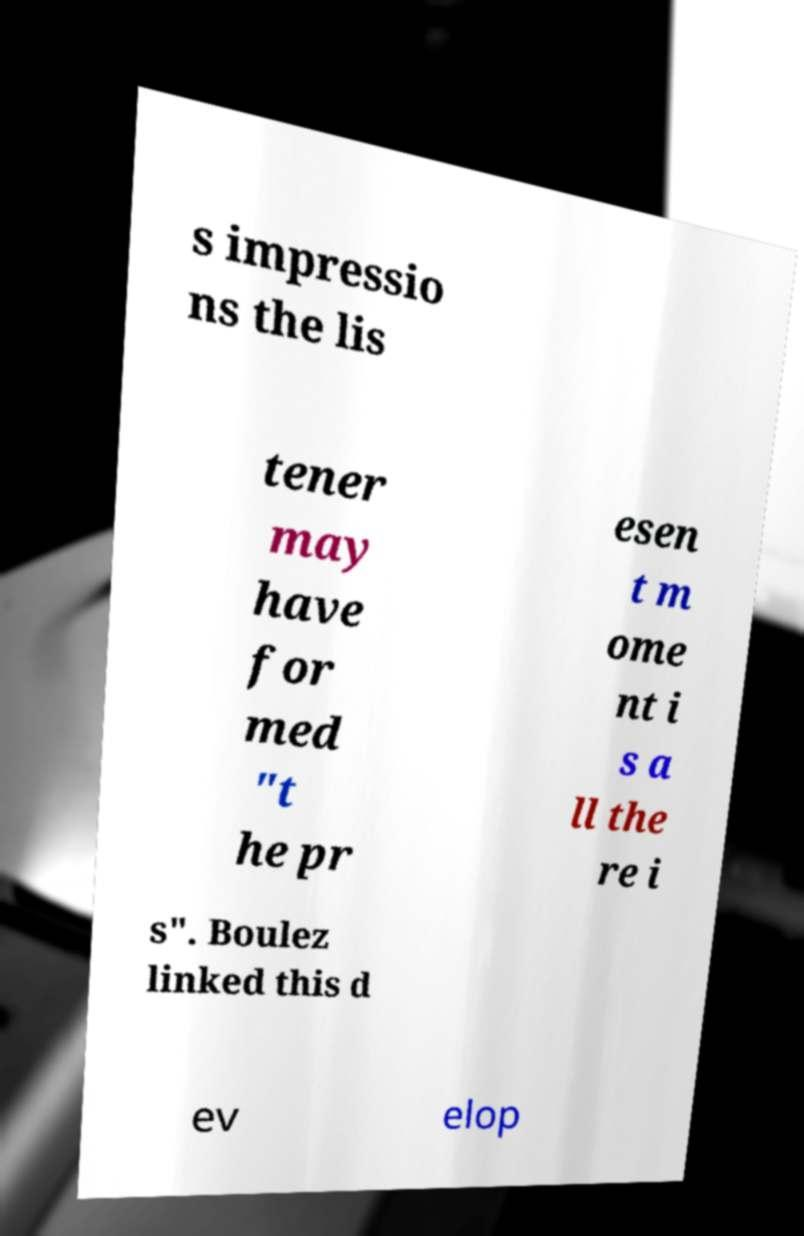Can you read and provide the text displayed in the image?This photo seems to have some interesting text. Can you extract and type it out for me? s impressio ns the lis tener may have for med "t he pr esen t m ome nt i s a ll the re i s". Boulez linked this d ev elop 